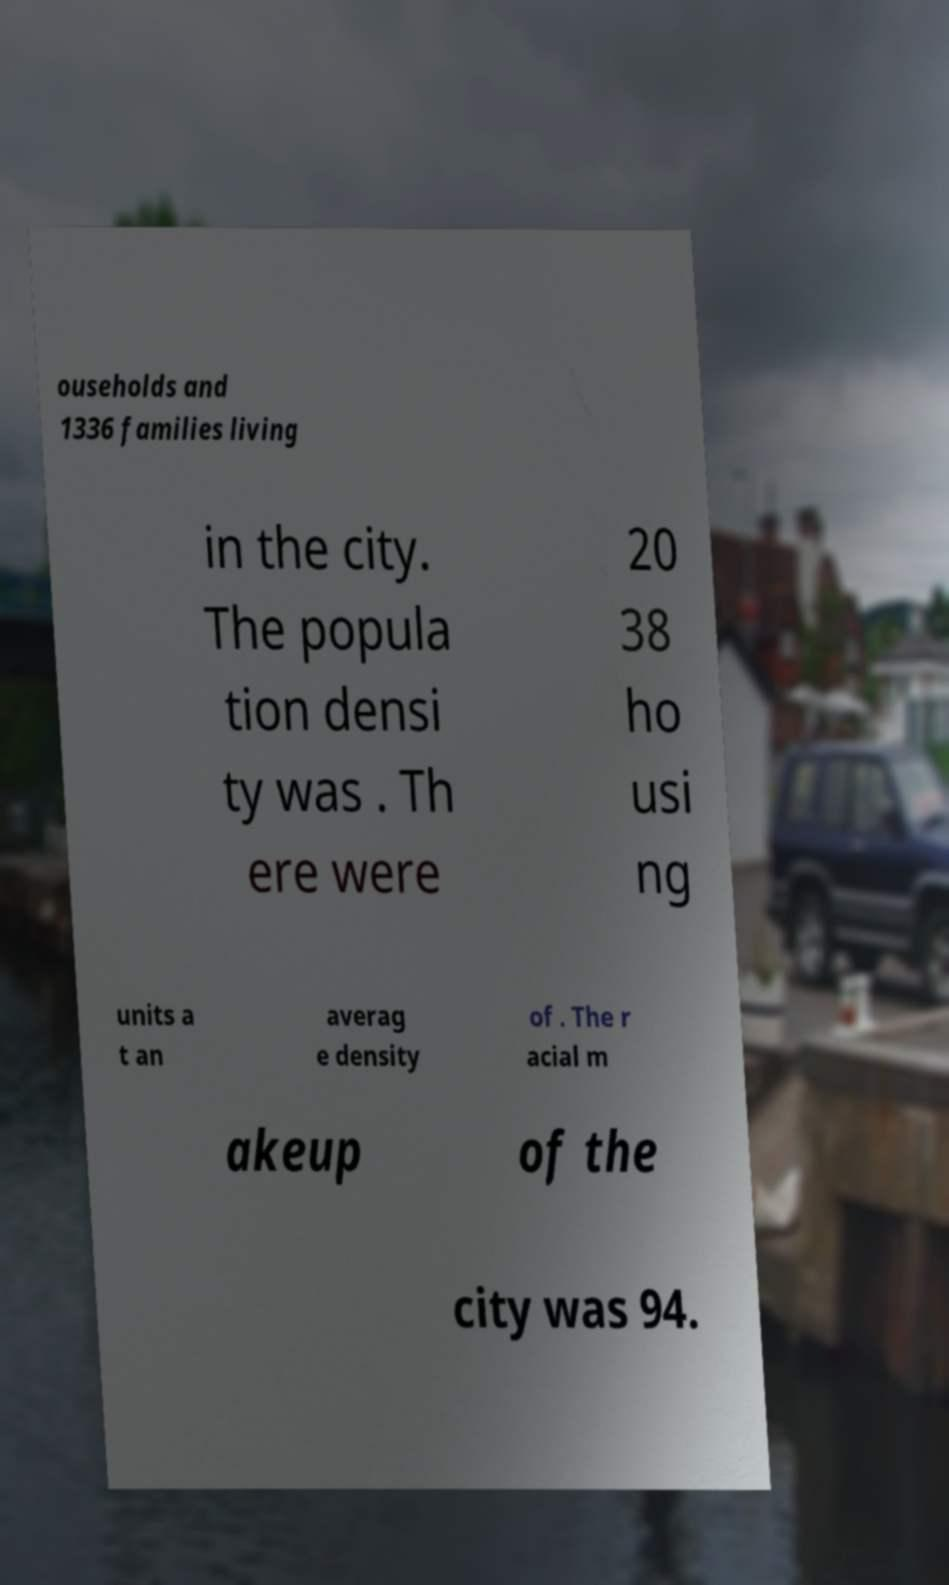Could you extract and type out the text from this image? ouseholds and 1336 families living in the city. The popula tion densi ty was . Th ere were 20 38 ho usi ng units a t an averag e density of . The r acial m akeup of the city was 94. 